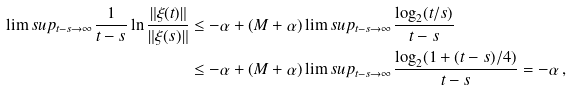Convert formula to latex. <formula><loc_0><loc_0><loc_500><loc_500>\lim s u p _ { t - s \to \infty } \frac { 1 } { t - s } \ln \frac { \| \xi ( t ) \| } { \| \xi ( s ) \| } & \leq - \alpha + ( M + \alpha ) \lim s u p _ { t - s \to \infty } \frac { \log _ { 2 } ( t / s ) } { t - s } \\ & \leq - \alpha + ( M + \alpha ) \lim s u p _ { t - s \to \infty } \frac { \log _ { 2 } ( 1 + ( t - s ) / 4 ) } { t - s } = - \alpha \, ,</formula> 